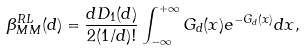Convert formula to latex. <formula><loc_0><loc_0><loc_500><loc_500>\beta _ { M M } ^ { R L } ( d ) = \frac { d D _ { 1 } ( d ) } { 2 ( 1 / d ) ! } \int _ { - \infty } ^ { + \infty } G _ { d } ( x ) e ^ { - G _ { d } ( x ) } d x ,</formula> 